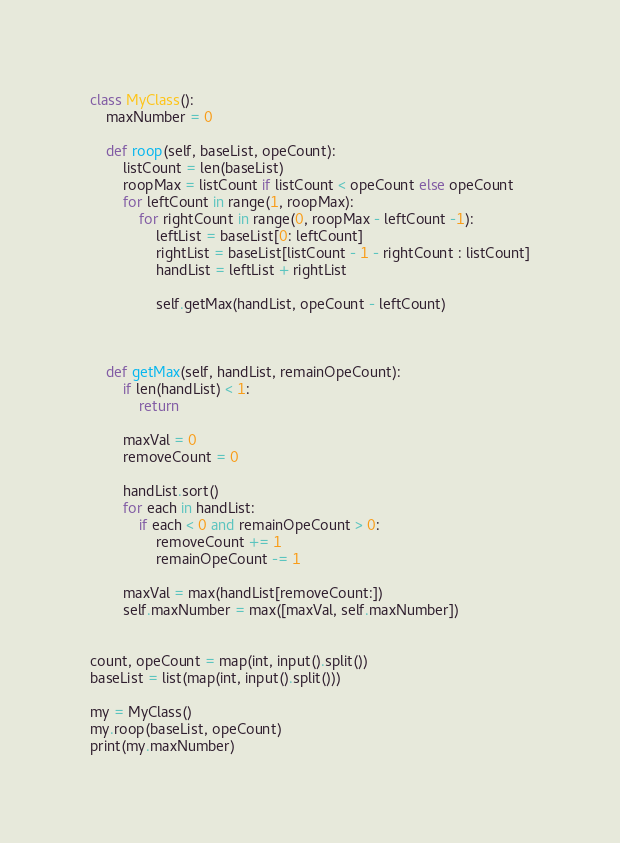<code> <loc_0><loc_0><loc_500><loc_500><_Python_>class MyClass():
    maxNumber = 0

    def roop(self, baseList, opeCount):
        listCount = len(baseList)
        roopMax = listCount if listCount < opeCount else opeCount
        for leftCount in range(1, roopMax):
            for rightCount in range(0, roopMax - leftCount -1):
                leftList = baseList[0: leftCount]
                rightList = baseList[listCount - 1 - rightCount : listCount]
                handList = leftList + rightList

                self.getMax(handList, opeCount - leftCount)

                

    def getMax(self, handList, remainOpeCount):
        if len(handList) < 1:
            return

        maxVal = 0
        removeCount = 0

        handList.sort()
        for each in handList:
            if each < 0 and remainOpeCount > 0:
                removeCount += 1
                remainOpeCount -= 1
        
        maxVal = max(handList[removeCount:])
        self.maxNumber = max([maxVal, self.maxNumber])


count, opeCount = map(int, input().split())
baseList = list(map(int, input().split()))

my = MyClass()
my.roop(baseList, opeCount)
print(my.maxNumber)





</code> 